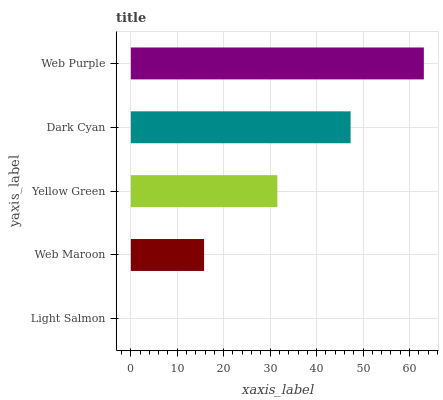Is Light Salmon the minimum?
Answer yes or no. Yes. Is Web Purple the maximum?
Answer yes or no. Yes. Is Web Maroon the minimum?
Answer yes or no. No. Is Web Maroon the maximum?
Answer yes or no. No. Is Web Maroon greater than Light Salmon?
Answer yes or no. Yes. Is Light Salmon less than Web Maroon?
Answer yes or no. Yes. Is Light Salmon greater than Web Maroon?
Answer yes or no. No. Is Web Maroon less than Light Salmon?
Answer yes or no. No. Is Yellow Green the high median?
Answer yes or no. Yes. Is Yellow Green the low median?
Answer yes or no. Yes. Is Web Purple the high median?
Answer yes or no. No. Is Web Purple the low median?
Answer yes or no. No. 